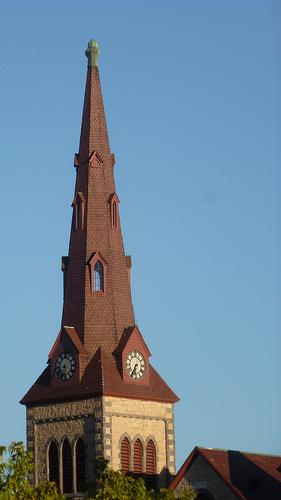Question: when was the picture taken?
Choices:
A. Sunset.
B. Evening.
C. Dusk.
D. Twilight.
Answer with the letter. Answer: A Question: why is the clock on the tower?
Choices:
A. To allow others to see the time.
B. For decoration.
C. To take up space.
D. It was a gift.
Answer with the letter. Answer: A Question: what color is the building?
Choices:
A. Gray.
B. Brown.
C. Beige.
D. White.
Answer with the letter. Answer: C 